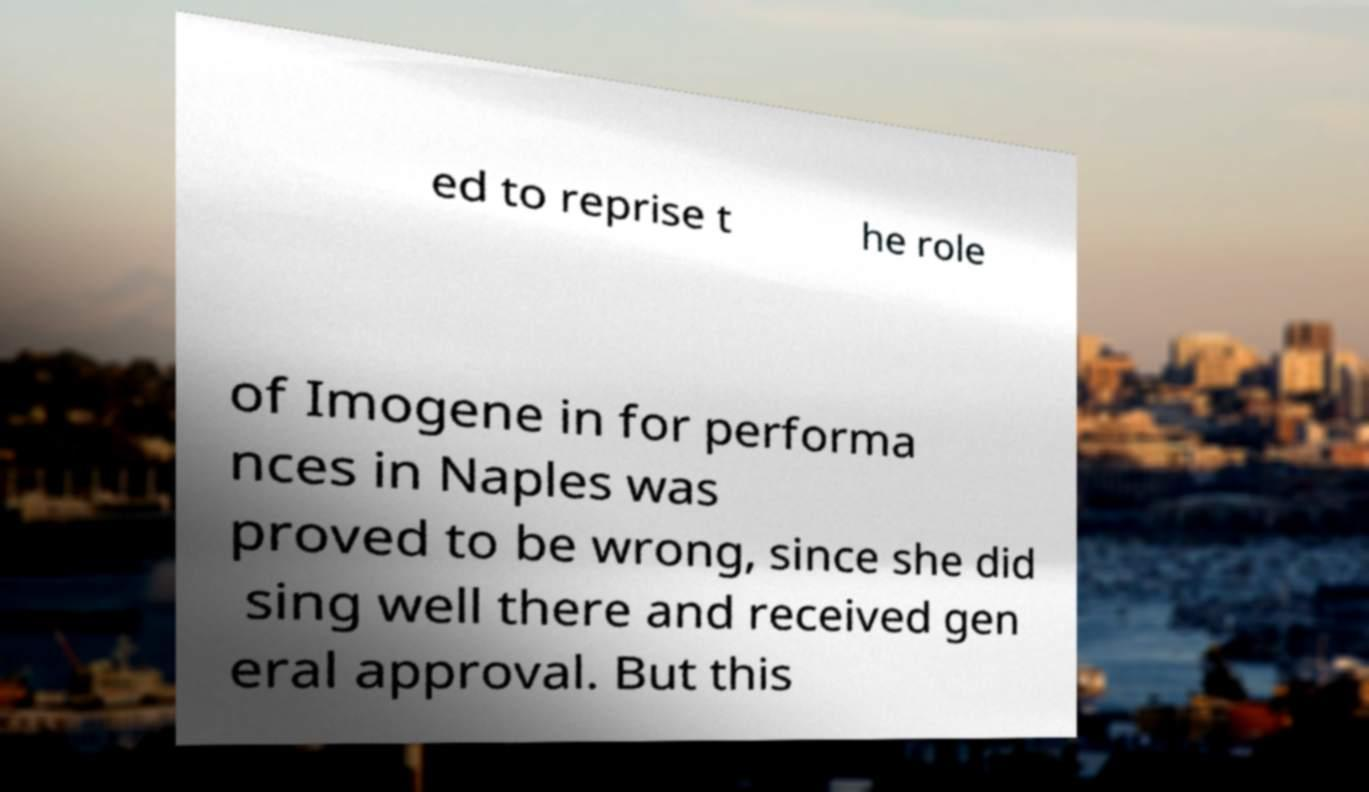Could you extract and type out the text from this image? ed to reprise t he role of Imogene in for performa nces in Naples was proved to be wrong, since she did sing well there and received gen eral approval. But this 